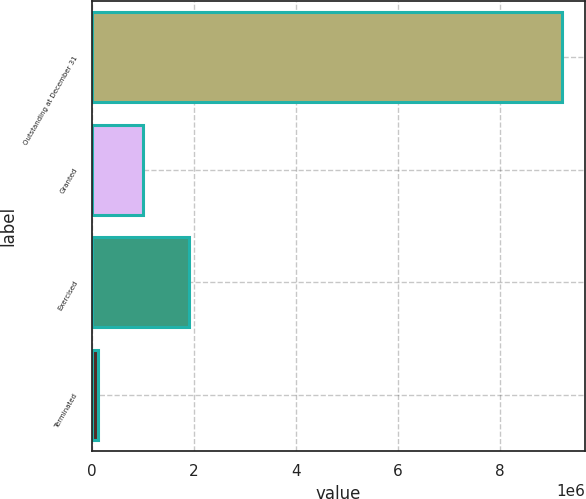Convert chart to OTSL. <chart><loc_0><loc_0><loc_500><loc_500><bar_chart><fcel>Outstanding at December 31<fcel>Granted<fcel>Exercised<fcel>Terminated<nl><fcel>9.20304e+06<fcel>1.00539e+06<fcel>1.89598e+06<fcel>114800<nl></chart> 